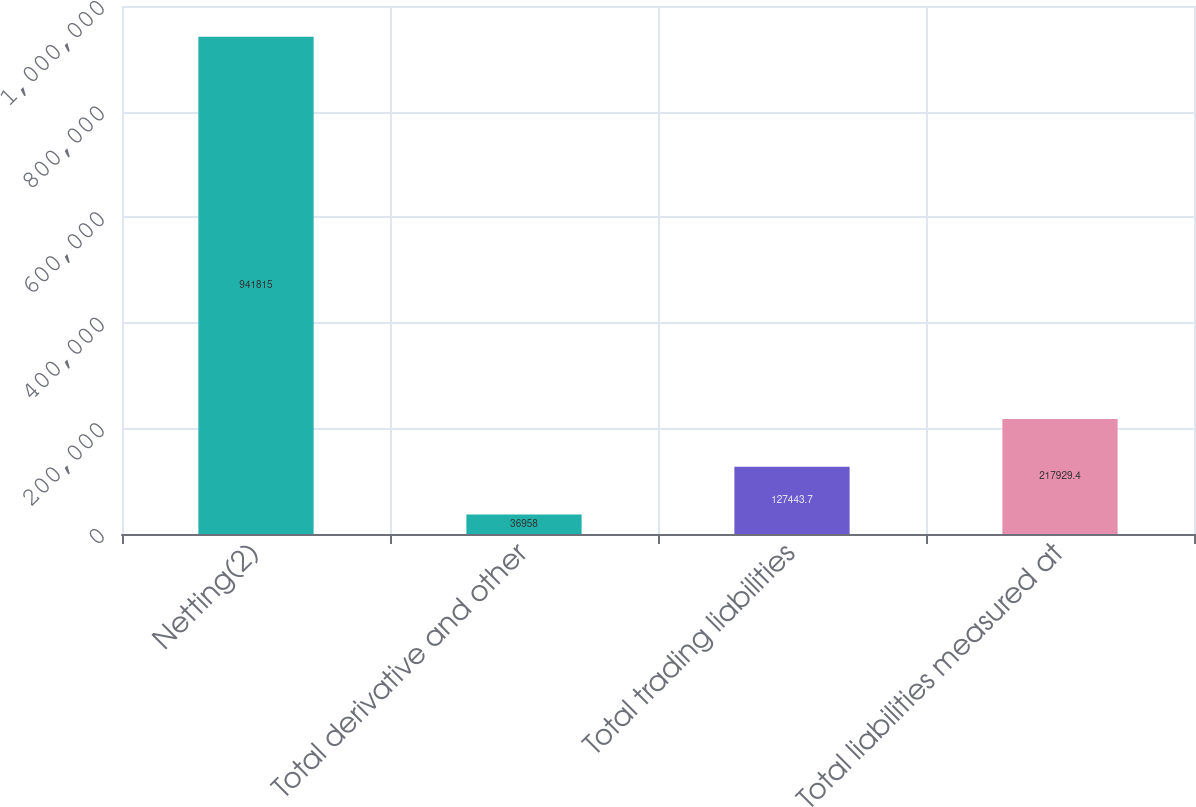Convert chart. <chart><loc_0><loc_0><loc_500><loc_500><bar_chart><fcel>Netting(2)<fcel>Total derivative and other<fcel>Total trading liabilities<fcel>Total liabilities measured at<nl><fcel>941815<fcel>36958<fcel>127444<fcel>217929<nl></chart> 